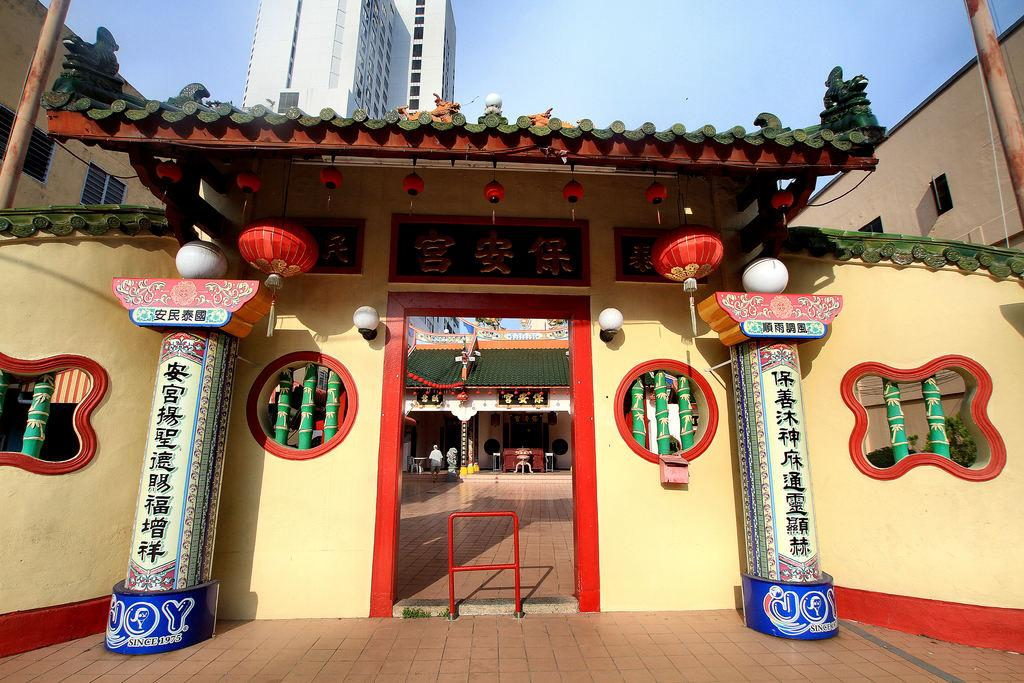What type of structures can be seen in the image? There are buildings in the image. Can you describe the entrance of a building in the foreground? Yes, there is an entrance of a building in the foreground. Is there anyone visible inside the building? Yes, a person is visible inside the building. What is visible at the top of the image? The sky is visible at the top of the image. What type of record can be seen being played in the image? There is no record or record player present in the image. 